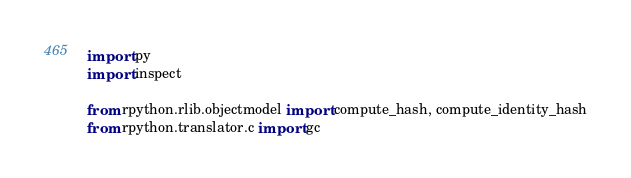Convert code to text. <code><loc_0><loc_0><loc_500><loc_500><_Python_>import py
import inspect

from rpython.rlib.objectmodel import compute_hash, compute_identity_hash
from rpython.translator.c import gc</code> 